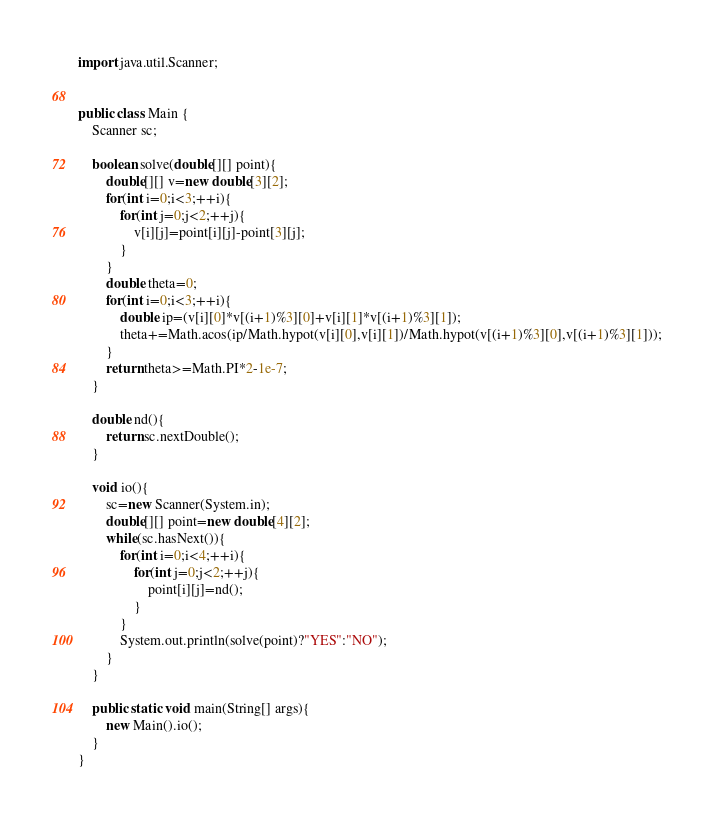Convert code to text. <code><loc_0><loc_0><loc_500><loc_500><_Java_>import java.util.Scanner;


public class Main {
	Scanner sc;
	
	boolean solve(double[][] point){
		double[][] v=new double[3][2];
		for(int i=0;i<3;++i){
			for(int j=0;j<2;++j){
				v[i][j]=point[i][j]-point[3][j];
			}
		}
		double theta=0;
		for(int i=0;i<3;++i){
			double ip=(v[i][0]*v[(i+1)%3][0]+v[i][1]*v[(i+1)%3][1]);
			theta+=Math.acos(ip/Math.hypot(v[i][0],v[i][1])/Math.hypot(v[(i+1)%3][0],v[(i+1)%3][1]));
		}
		return theta>=Math.PI*2-1e-7;
	}
	
	double nd(){
		return sc.nextDouble();
	}
	
	void io(){
		sc=new Scanner(System.in);
		double[][] point=new double[4][2];
		while(sc.hasNext()){
			for(int i=0;i<4;++i){
				for(int j=0;j<2;++j){
					point[i][j]=nd();
				}
			}
			System.out.println(solve(point)?"YES":"NO");
		}
	}
	
	public static void main(String[] args){
		new Main().io();
	}
}</code> 